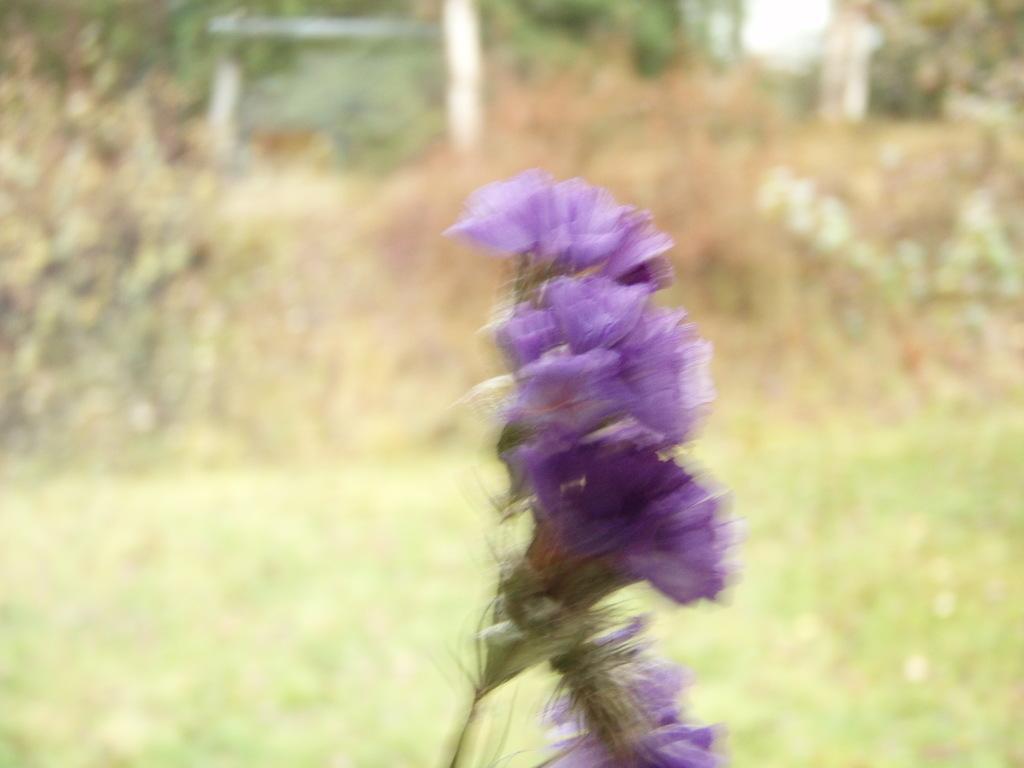Please provide a concise description of this image. In this picture we can see blue color Lily flower in the image. Behind we can see blur background. 